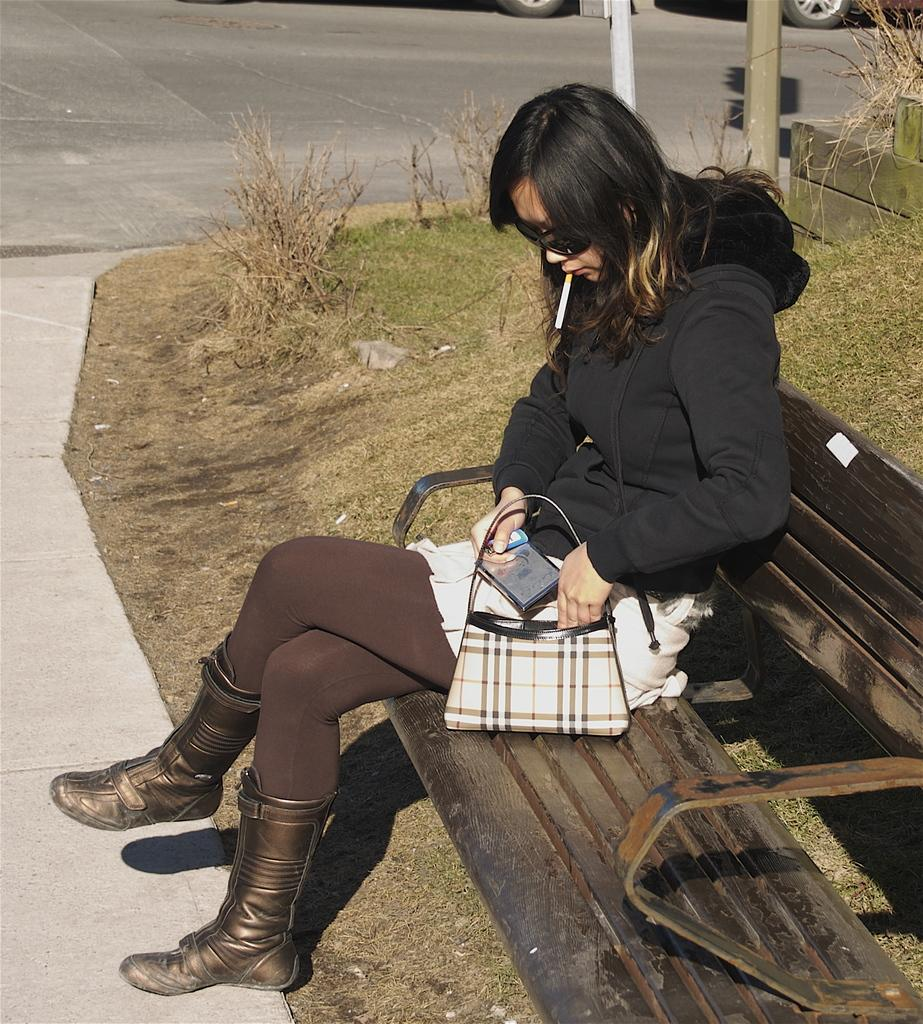Who is present in the image? There is a woman in the image. What is the woman wearing? The woman is wearing a black dress. Where is the woman sitting? The woman is sitting on a bench. What is the location of the bench? The bench is beside the road. What is the woman holding? The woman is holding a purse. What is the woman doing with her mouth? The woman has a cigarette in her mouth. What type of vegetation can be seen in the image? There is grass visible in the image. What is the value of the letter the woman is holding in the image? The woman is not holding a letter in the image; she is holding a purse. 